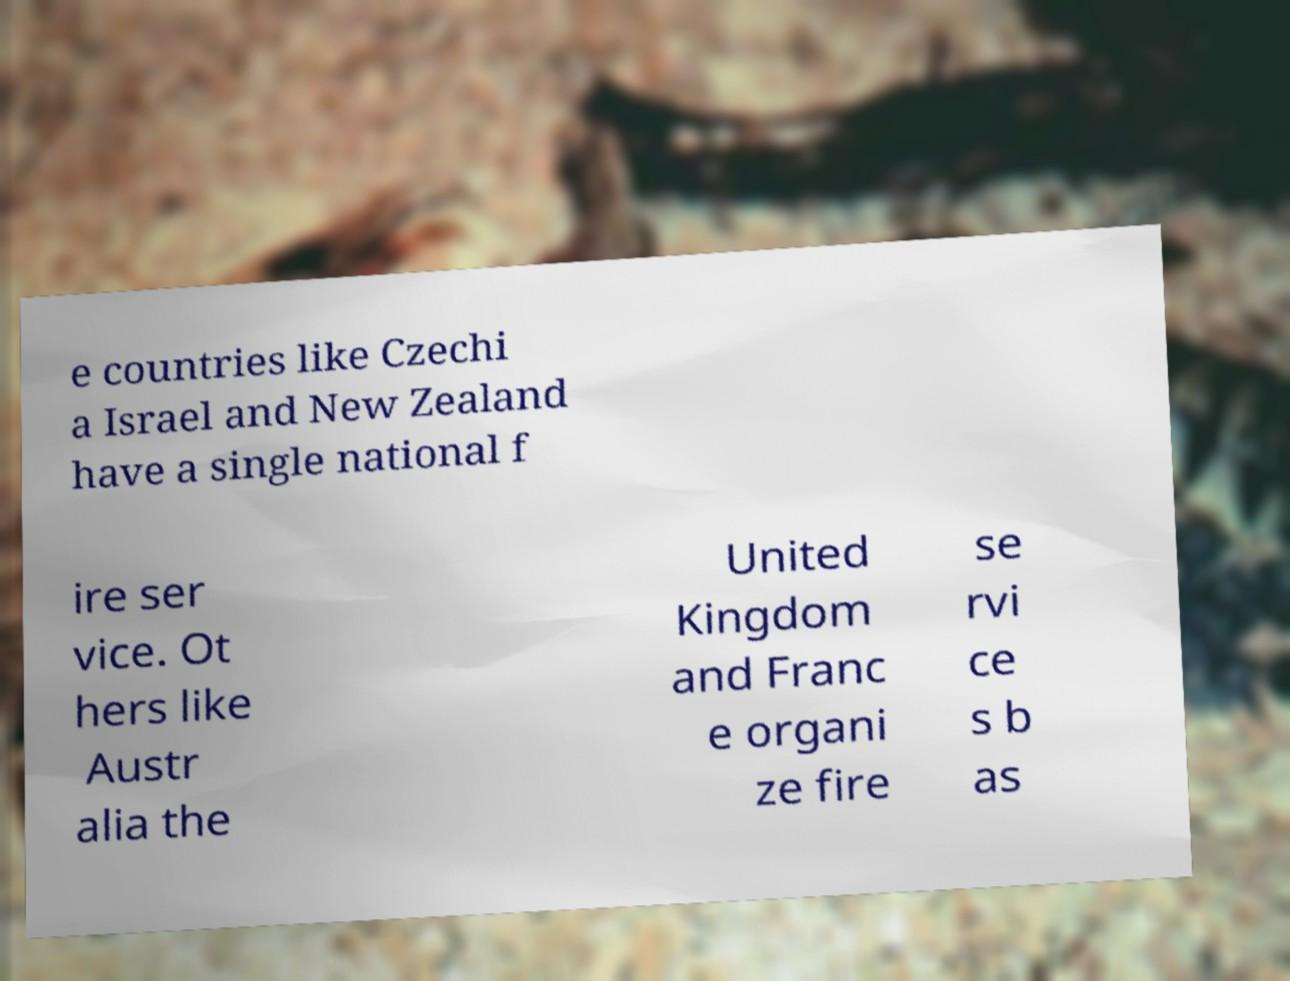Could you assist in decoding the text presented in this image and type it out clearly? e countries like Czechi a Israel and New Zealand have a single national f ire ser vice. Ot hers like Austr alia the United Kingdom and Franc e organi ze fire se rvi ce s b as 